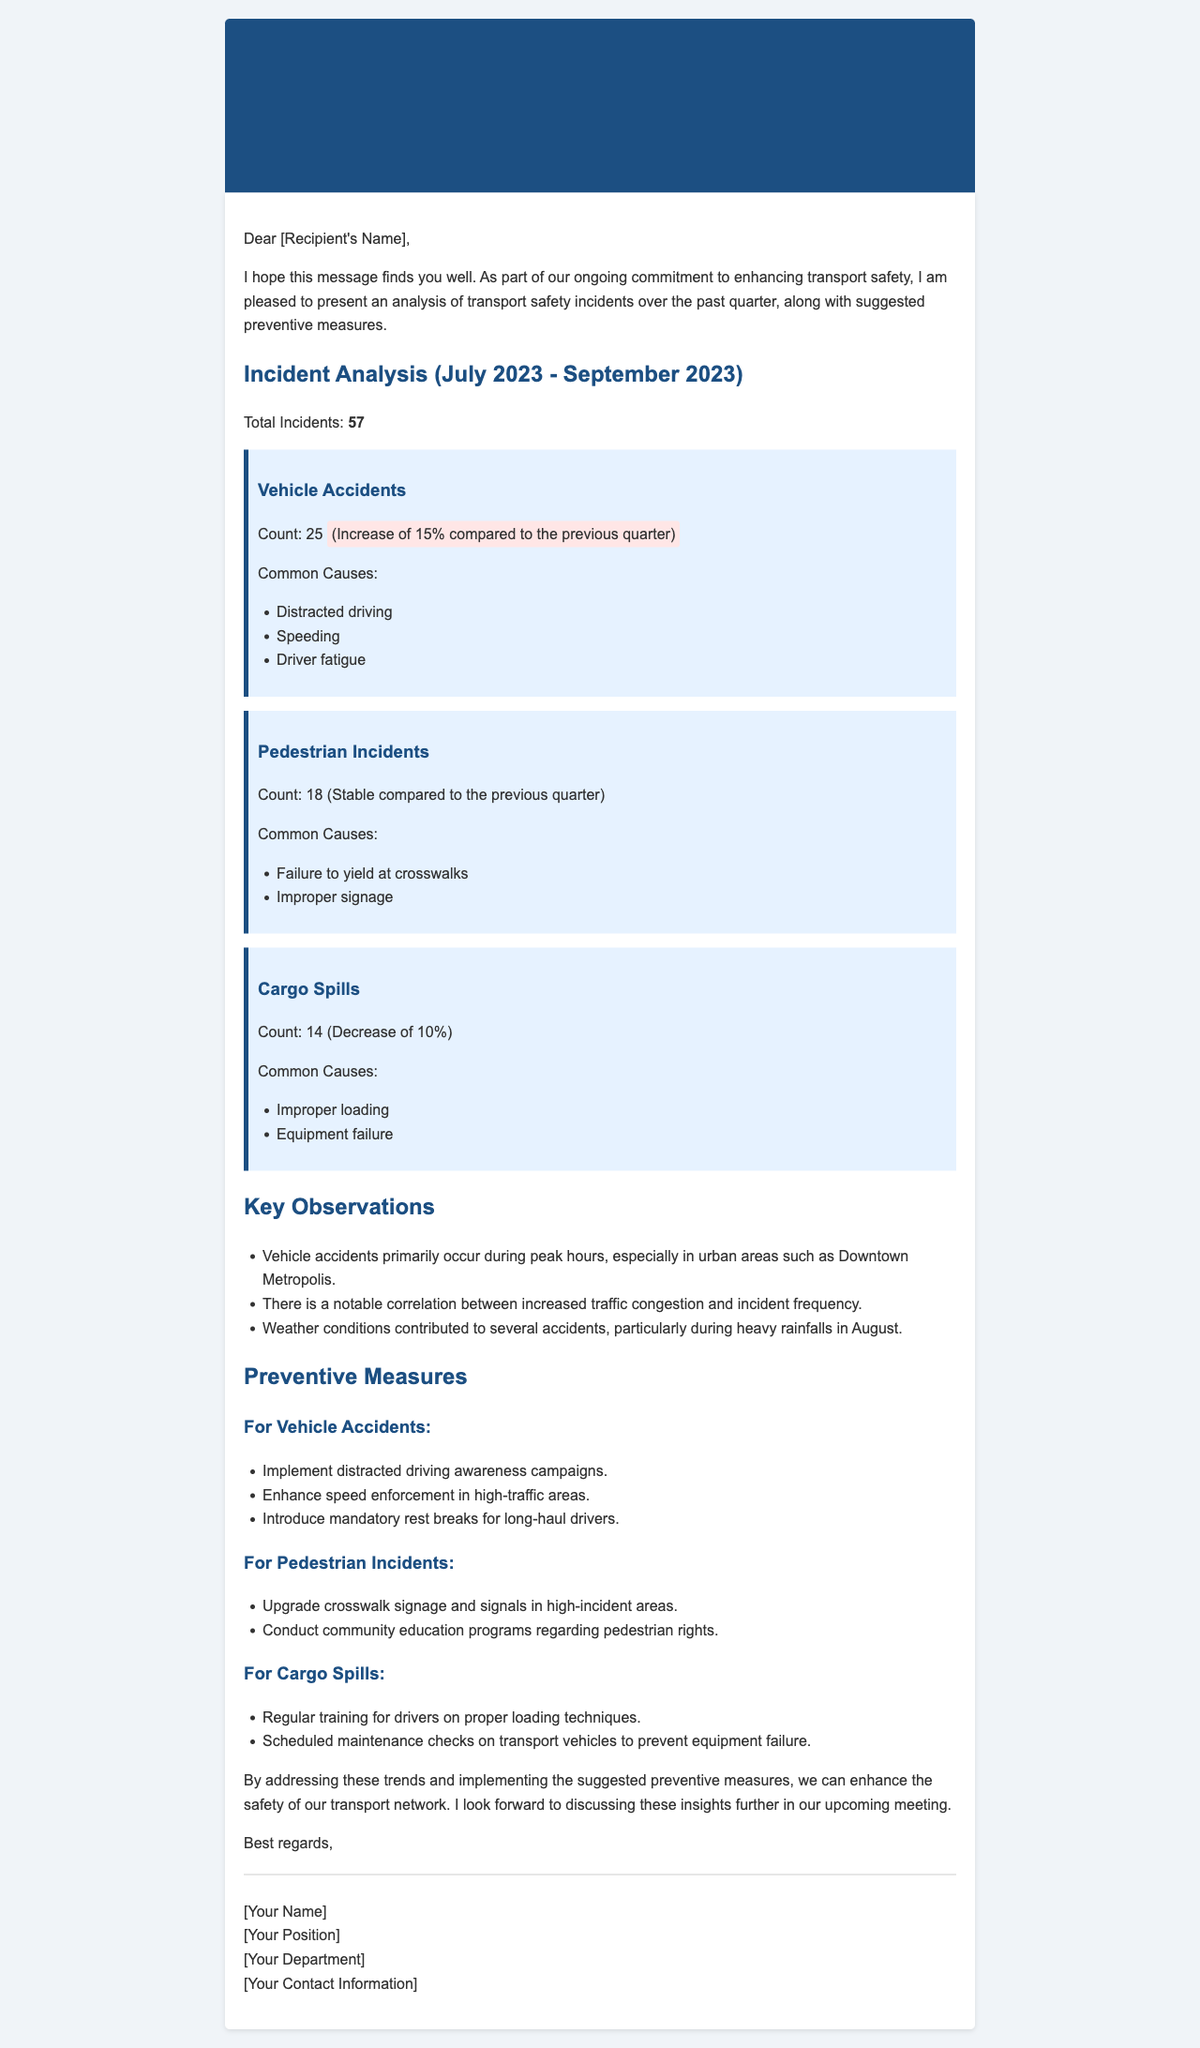what is the total number of incidents reported? The total number of incidents reported in the document is explicitly mentioned under the Incident Analysis section.
Answer: 57 how many vehicle accidents were reported? The number of vehicle accidents is detailed under the Vehicle Accidents category in the document.
Answer: 25 what was the percentage increase in vehicle accidents compared to the previous quarter? The percentage increase is clearly stated next to the count of vehicle accidents.
Answer: 15% what were the common causes of pedestrian incidents? The common causes of pedestrian incidents are listed in the Pedestrian Incidents section.
Answer: Failure to yield at crosswalks, Improper signage which category had a decrease in incidents? The category with a decrease in incidents is identified within the Cargo Spills section of the document.
Answer: Cargo Spills what is one key observation mentioned in the report? Key observations are listed in the Key Observations section and provide insights into trends noticed during the quarter.
Answer: Vehicle accidents primarily occur during peak hours what is a suggested preventive measure for pedestrian incidents? Preventive measures for pedestrian incidents are provided under the Preventive Measures section of the document.
Answer: Upgrade crosswalk signage and signals in high-incident areas who is the author of the report? The author's information is provided in the signature part of the document.
Answer: [Your Name] 